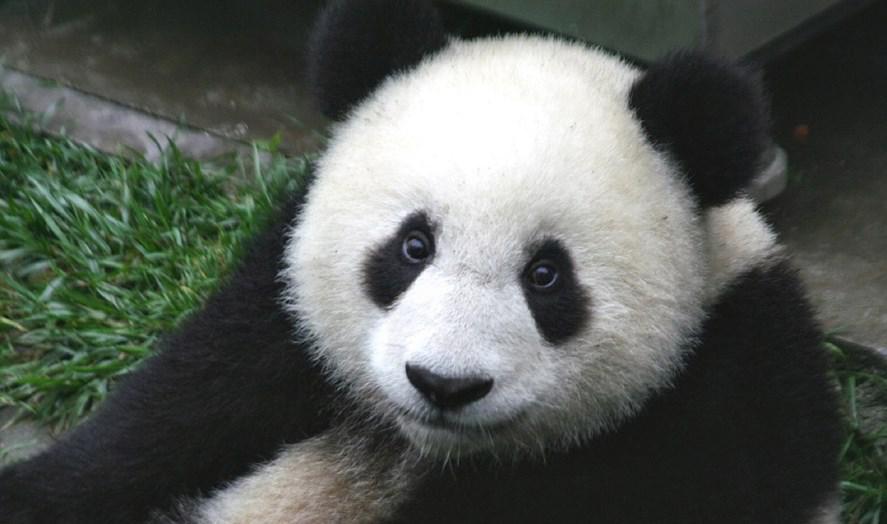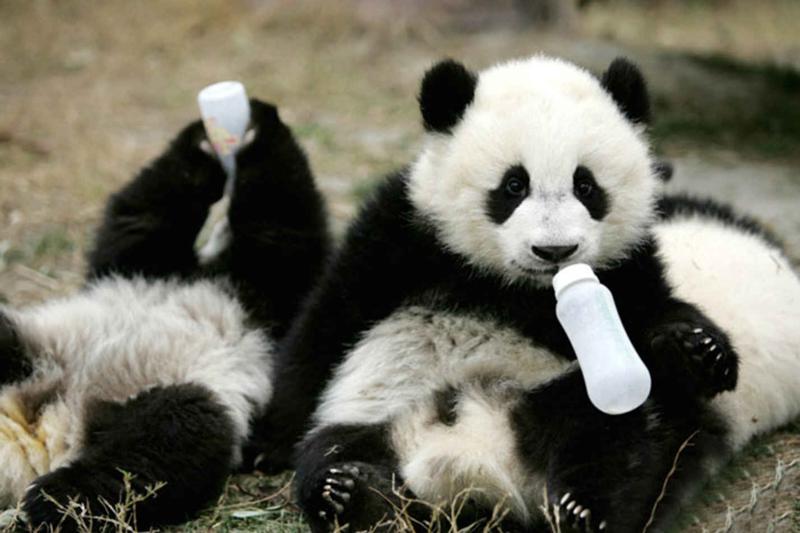The first image is the image on the left, the second image is the image on the right. Given the left and right images, does the statement "Right image contains twice as many panda bears as the left image." hold true? Answer yes or no. Yes. 